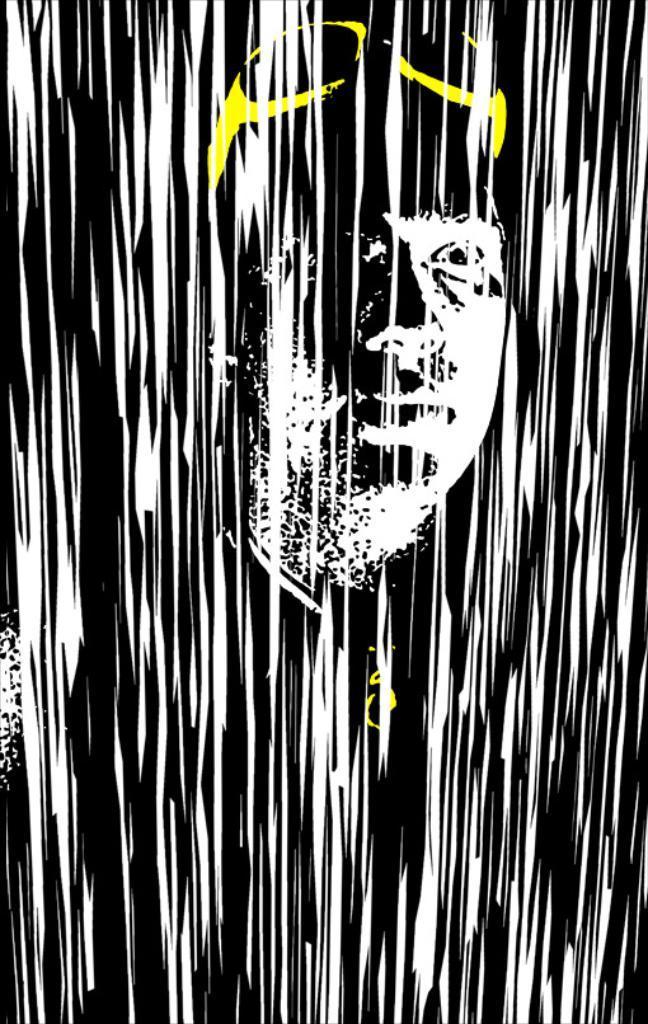Could you give a brief overview of what you see in this image? In this image we can see the animation of a man. 